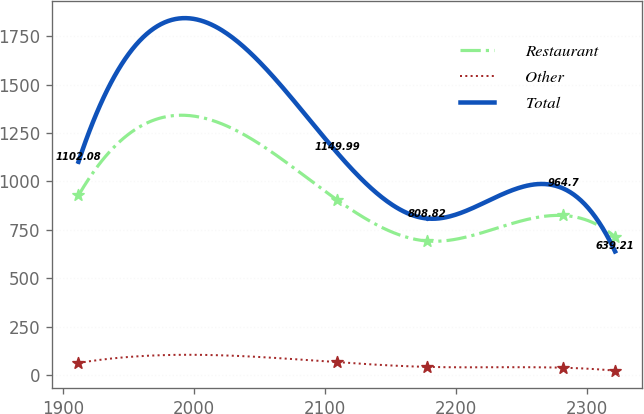<chart> <loc_0><loc_0><loc_500><loc_500><line_chart><ecel><fcel>Restaurant<fcel>Other<fcel>Total<nl><fcel>1911.56<fcel>928.07<fcel>64.01<fcel>1102.08<nl><fcel>2108.9<fcel>905.85<fcel>68.24<fcel>1149.99<nl><fcel>2178.08<fcel>692.72<fcel>43.75<fcel>808.82<nl><fcel>2281.57<fcel>824.51<fcel>39.52<fcel>964.7<nl><fcel>2321.44<fcel>714.94<fcel>24.2<fcel>639.21<nl></chart> 